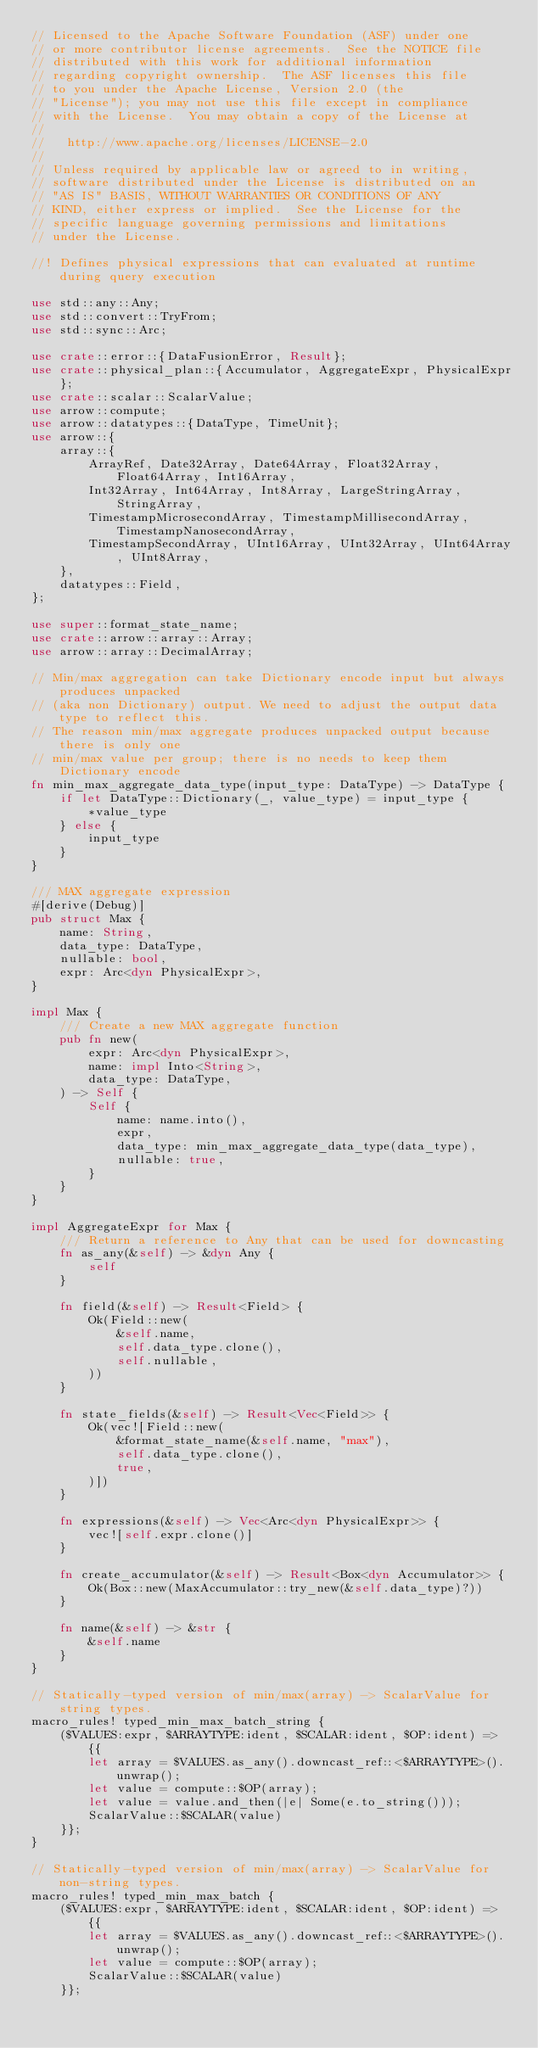<code> <loc_0><loc_0><loc_500><loc_500><_Rust_>// Licensed to the Apache Software Foundation (ASF) under one
// or more contributor license agreements.  See the NOTICE file
// distributed with this work for additional information
// regarding copyright ownership.  The ASF licenses this file
// to you under the Apache License, Version 2.0 (the
// "License"); you may not use this file except in compliance
// with the License.  You may obtain a copy of the License at
//
//   http://www.apache.org/licenses/LICENSE-2.0
//
// Unless required by applicable law or agreed to in writing,
// software distributed under the License is distributed on an
// "AS IS" BASIS, WITHOUT WARRANTIES OR CONDITIONS OF ANY
// KIND, either express or implied.  See the License for the
// specific language governing permissions and limitations
// under the License.

//! Defines physical expressions that can evaluated at runtime during query execution

use std::any::Any;
use std::convert::TryFrom;
use std::sync::Arc;

use crate::error::{DataFusionError, Result};
use crate::physical_plan::{Accumulator, AggregateExpr, PhysicalExpr};
use crate::scalar::ScalarValue;
use arrow::compute;
use arrow::datatypes::{DataType, TimeUnit};
use arrow::{
    array::{
        ArrayRef, Date32Array, Date64Array, Float32Array, Float64Array, Int16Array,
        Int32Array, Int64Array, Int8Array, LargeStringArray, StringArray,
        TimestampMicrosecondArray, TimestampMillisecondArray, TimestampNanosecondArray,
        TimestampSecondArray, UInt16Array, UInt32Array, UInt64Array, UInt8Array,
    },
    datatypes::Field,
};

use super::format_state_name;
use crate::arrow::array::Array;
use arrow::array::DecimalArray;

// Min/max aggregation can take Dictionary encode input but always produces unpacked
// (aka non Dictionary) output. We need to adjust the output data type to reflect this.
// The reason min/max aggregate produces unpacked output because there is only one
// min/max value per group; there is no needs to keep them Dictionary encode
fn min_max_aggregate_data_type(input_type: DataType) -> DataType {
    if let DataType::Dictionary(_, value_type) = input_type {
        *value_type
    } else {
        input_type
    }
}

/// MAX aggregate expression
#[derive(Debug)]
pub struct Max {
    name: String,
    data_type: DataType,
    nullable: bool,
    expr: Arc<dyn PhysicalExpr>,
}

impl Max {
    /// Create a new MAX aggregate function
    pub fn new(
        expr: Arc<dyn PhysicalExpr>,
        name: impl Into<String>,
        data_type: DataType,
    ) -> Self {
        Self {
            name: name.into(),
            expr,
            data_type: min_max_aggregate_data_type(data_type),
            nullable: true,
        }
    }
}

impl AggregateExpr for Max {
    /// Return a reference to Any that can be used for downcasting
    fn as_any(&self) -> &dyn Any {
        self
    }

    fn field(&self) -> Result<Field> {
        Ok(Field::new(
            &self.name,
            self.data_type.clone(),
            self.nullable,
        ))
    }

    fn state_fields(&self) -> Result<Vec<Field>> {
        Ok(vec![Field::new(
            &format_state_name(&self.name, "max"),
            self.data_type.clone(),
            true,
        )])
    }

    fn expressions(&self) -> Vec<Arc<dyn PhysicalExpr>> {
        vec![self.expr.clone()]
    }

    fn create_accumulator(&self) -> Result<Box<dyn Accumulator>> {
        Ok(Box::new(MaxAccumulator::try_new(&self.data_type)?))
    }

    fn name(&self) -> &str {
        &self.name
    }
}

// Statically-typed version of min/max(array) -> ScalarValue for string types.
macro_rules! typed_min_max_batch_string {
    ($VALUES:expr, $ARRAYTYPE:ident, $SCALAR:ident, $OP:ident) => {{
        let array = $VALUES.as_any().downcast_ref::<$ARRAYTYPE>().unwrap();
        let value = compute::$OP(array);
        let value = value.and_then(|e| Some(e.to_string()));
        ScalarValue::$SCALAR(value)
    }};
}

// Statically-typed version of min/max(array) -> ScalarValue for non-string types.
macro_rules! typed_min_max_batch {
    ($VALUES:expr, $ARRAYTYPE:ident, $SCALAR:ident, $OP:ident) => {{
        let array = $VALUES.as_any().downcast_ref::<$ARRAYTYPE>().unwrap();
        let value = compute::$OP(array);
        ScalarValue::$SCALAR(value)
    }};
</code> 